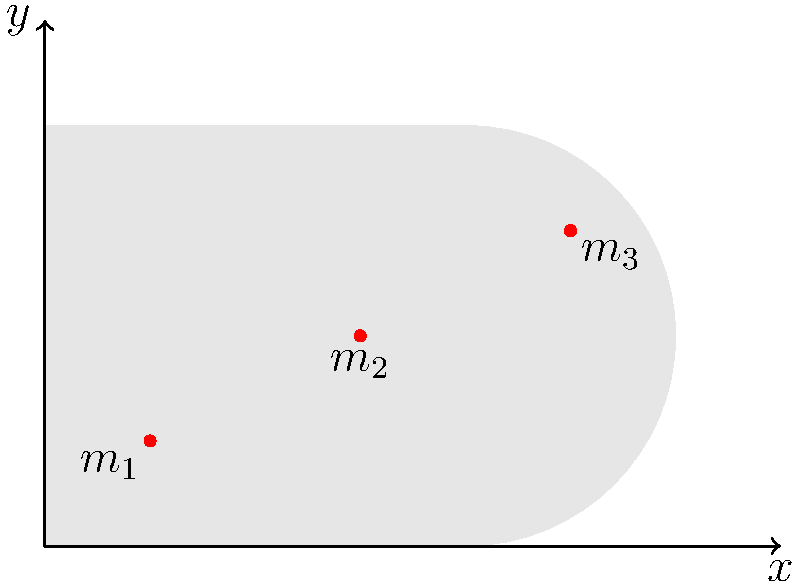A complex prosthetic limb is represented by the shape shown in the diagram. Three mass points are located within the limb: $m_1 = 100$ g at (0.5, 0.5) cm, $m_2 = 150$ g at (1.5, 1.0) cm, and $m_3 = 200$ g at (2.5, 1.5) cm. Calculate the x-coordinate of the center of mass for this prosthetic limb. To find the x-coordinate of the center of mass, we'll use the formula:

$$x_{CM} = \frac{\sum m_i x_i}{\sum m_i}$$

Where $m_i$ is the mass of each point and $x_i$ is its x-coordinate.

Step 1: Calculate the sum of masses:
$$\sum m_i = m_1 + m_2 + m_3 = 100 + 150 + 200 = 450 \text{ g}$$

Step 2: Calculate the sum of mass-weighted x-coordinates:
$$\sum m_i x_i = (100 \times 0.5) + (150 \times 1.5) + (200 \times 2.5)$$
$$= 50 + 225 + 500 = 775 \text{ g⋅cm}$$

Step 3: Apply the center of mass formula:
$$x_{CM} = \frac{775 \text{ g⋅cm}}{450 \text{ g}} = 1.72 \text{ cm}$$

Therefore, the x-coordinate of the center of mass is 1.72 cm.
Answer: 1.72 cm 